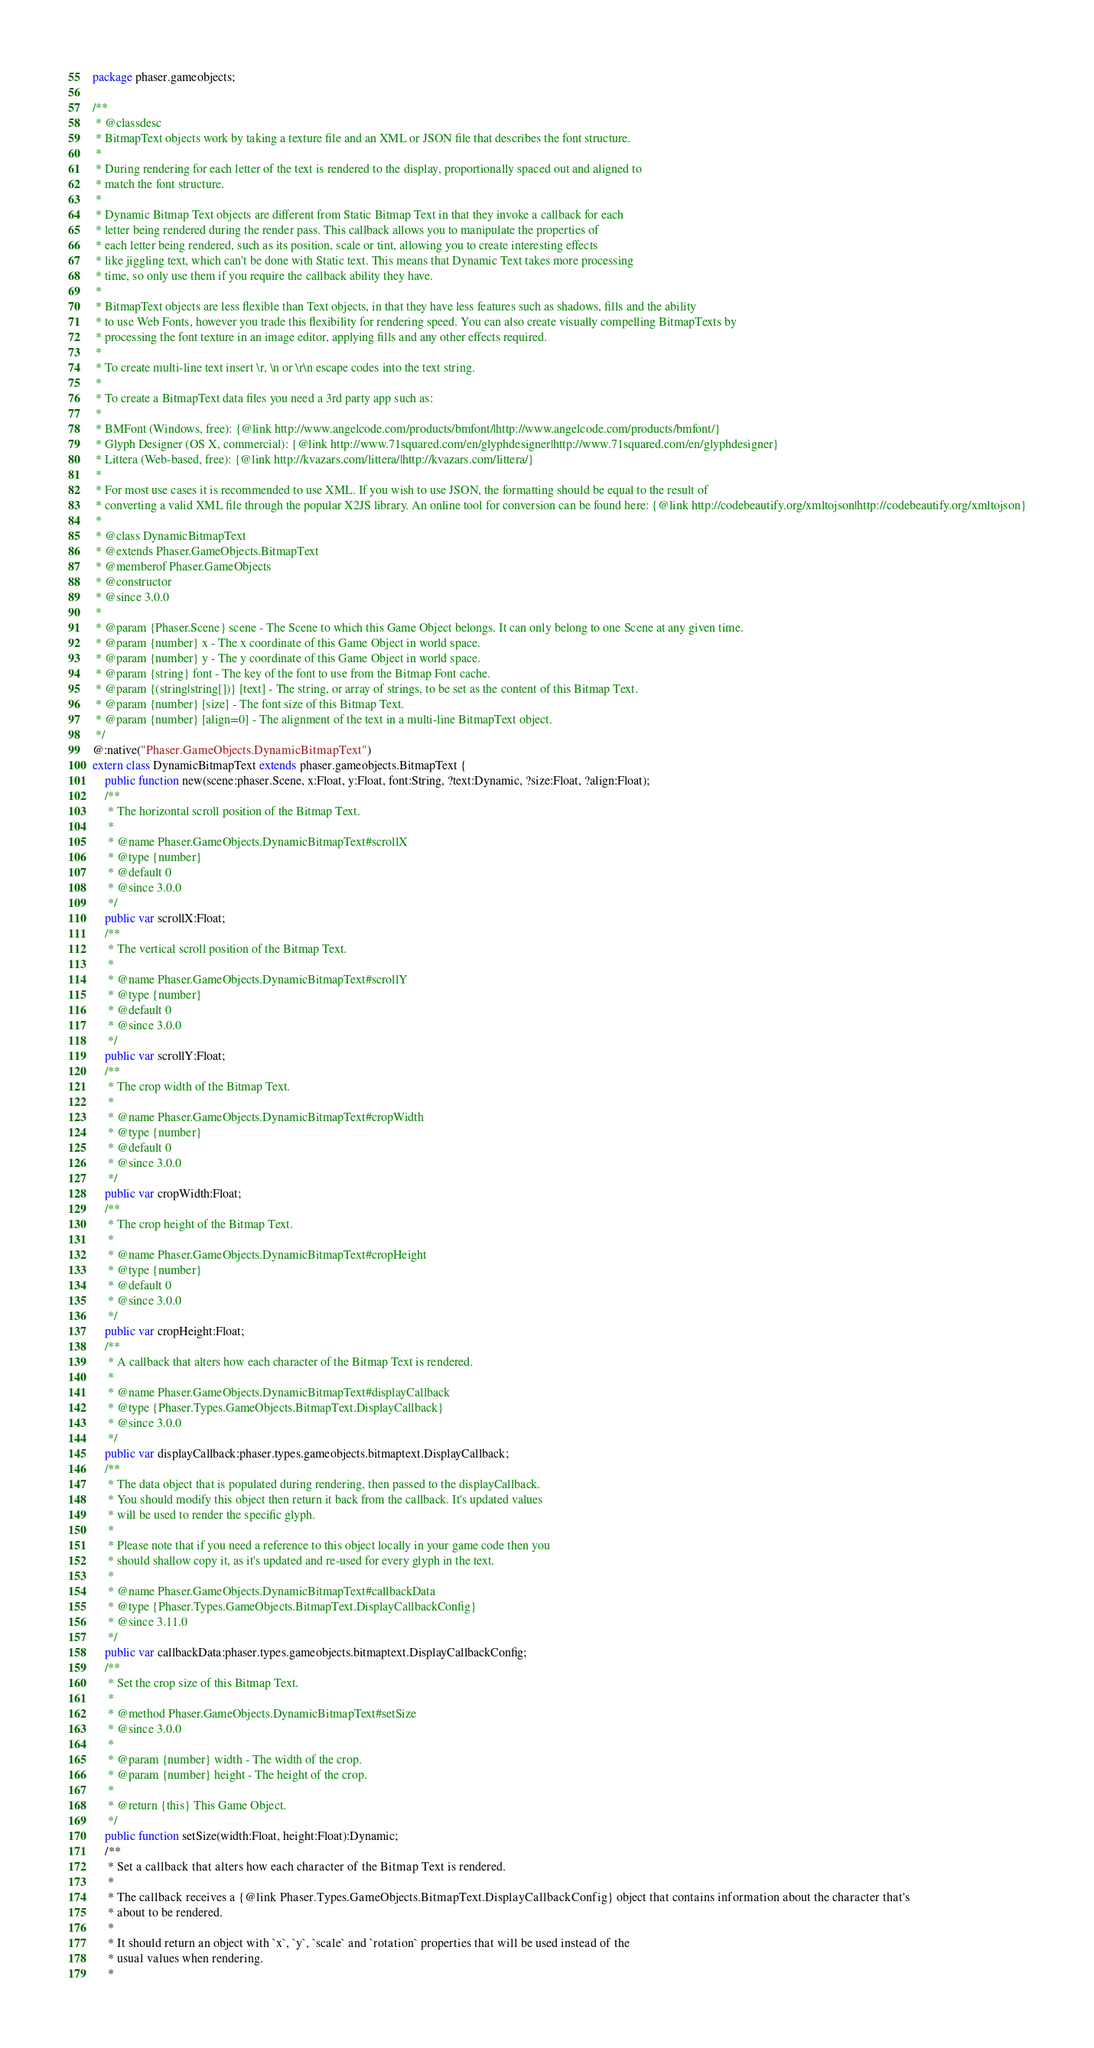Convert code to text. <code><loc_0><loc_0><loc_500><loc_500><_Haxe_>package phaser.gameobjects;

/**
 * @classdesc
 * BitmapText objects work by taking a texture file and an XML or JSON file that describes the font structure.
 *
 * During rendering for each letter of the text is rendered to the display, proportionally spaced out and aligned to
 * match the font structure.
 *
 * Dynamic Bitmap Text objects are different from Static Bitmap Text in that they invoke a callback for each
 * letter being rendered during the render pass. This callback allows you to manipulate the properties of
 * each letter being rendered, such as its position, scale or tint, allowing you to create interesting effects
 * like jiggling text, which can't be done with Static text. This means that Dynamic Text takes more processing
 * time, so only use them if you require the callback ability they have.
 *
 * BitmapText objects are less flexible than Text objects, in that they have less features such as shadows, fills and the ability
 * to use Web Fonts, however you trade this flexibility for rendering speed. You can also create visually compelling BitmapTexts by
 * processing the font texture in an image editor, applying fills and any other effects required.
 *
 * To create multi-line text insert \r, \n or \r\n escape codes into the text string.
 *
 * To create a BitmapText data files you need a 3rd party app such as:
 *
 * BMFont (Windows, free): {@link http://www.angelcode.com/products/bmfont/|http://www.angelcode.com/products/bmfont/}
 * Glyph Designer (OS X, commercial): {@link http://www.71squared.com/en/glyphdesigner|http://www.71squared.com/en/glyphdesigner}
 * Littera (Web-based, free): {@link http://kvazars.com/littera/|http://kvazars.com/littera/}
 *
 * For most use cases it is recommended to use XML. If you wish to use JSON, the formatting should be equal to the result of
 * converting a valid XML file through the popular X2JS library. An online tool for conversion can be found here: {@link http://codebeautify.org/xmltojson|http://codebeautify.org/xmltojson}
 *
 * @class DynamicBitmapText
 * @extends Phaser.GameObjects.BitmapText
 * @memberof Phaser.GameObjects
 * @constructor
 * @since 3.0.0
 *
 * @param {Phaser.Scene} scene - The Scene to which this Game Object belongs. It can only belong to one Scene at any given time.
 * @param {number} x - The x coordinate of this Game Object in world space.
 * @param {number} y - The y coordinate of this Game Object in world space.
 * @param {string} font - The key of the font to use from the Bitmap Font cache.
 * @param {(string|string[])} [text] - The string, or array of strings, to be set as the content of this Bitmap Text.
 * @param {number} [size] - The font size of this Bitmap Text.
 * @param {number} [align=0] - The alignment of the text in a multi-line BitmapText object.
 */
@:native("Phaser.GameObjects.DynamicBitmapText")
extern class DynamicBitmapText extends phaser.gameobjects.BitmapText {
    public function new(scene:phaser.Scene, x:Float, y:Float, font:String, ?text:Dynamic, ?size:Float, ?align:Float);
    /**
     * The horizontal scroll position of the Bitmap Text.
     *
     * @name Phaser.GameObjects.DynamicBitmapText#scrollX
     * @type {number}
     * @default 0
     * @since 3.0.0
     */
    public var scrollX:Float;
    /**
     * The vertical scroll position of the Bitmap Text.
     *
     * @name Phaser.GameObjects.DynamicBitmapText#scrollY
     * @type {number}
     * @default 0
     * @since 3.0.0
     */
    public var scrollY:Float;
    /**
     * The crop width of the Bitmap Text.
     *
     * @name Phaser.GameObjects.DynamicBitmapText#cropWidth
     * @type {number}
     * @default 0
     * @since 3.0.0
     */
    public var cropWidth:Float;
    /**
     * The crop height of the Bitmap Text.
     *
     * @name Phaser.GameObjects.DynamicBitmapText#cropHeight
     * @type {number}
     * @default 0
     * @since 3.0.0
     */
    public var cropHeight:Float;
    /**
     * A callback that alters how each character of the Bitmap Text is rendered.
     *
     * @name Phaser.GameObjects.DynamicBitmapText#displayCallback
     * @type {Phaser.Types.GameObjects.BitmapText.DisplayCallback}
     * @since 3.0.0
     */
    public var displayCallback:phaser.types.gameobjects.bitmaptext.DisplayCallback;
    /**
     * The data object that is populated during rendering, then passed to the displayCallback.
     * You should modify this object then return it back from the callback. It's updated values
     * will be used to render the specific glyph.
     *
     * Please note that if you need a reference to this object locally in your game code then you
     * should shallow copy it, as it's updated and re-used for every glyph in the text.
     *
     * @name Phaser.GameObjects.DynamicBitmapText#callbackData
     * @type {Phaser.Types.GameObjects.BitmapText.DisplayCallbackConfig}
     * @since 3.11.0
     */
    public var callbackData:phaser.types.gameobjects.bitmaptext.DisplayCallbackConfig;
    /**
     * Set the crop size of this Bitmap Text.
     *
     * @method Phaser.GameObjects.DynamicBitmapText#setSize
     * @since 3.0.0
     *
     * @param {number} width - The width of the crop.
     * @param {number} height - The height of the crop.
     *
     * @return {this} This Game Object.
     */
    public function setSize(width:Float, height:Float):Dynamic;
    /**
     * Set a callback that alters how each character of the Bitmap Text is rendered.
     *
     * The callback receives a {@link Phaser.Types.GameObjects.BitmapText.DisplayCallbackConfig} object that contains information about the character that's
     * about to be rendered.
     *
     * It should return an object with `x`, `y`, `scale` and `rotation` properties that will be used instead of the
     * usual values when rendering.
     *</code> 